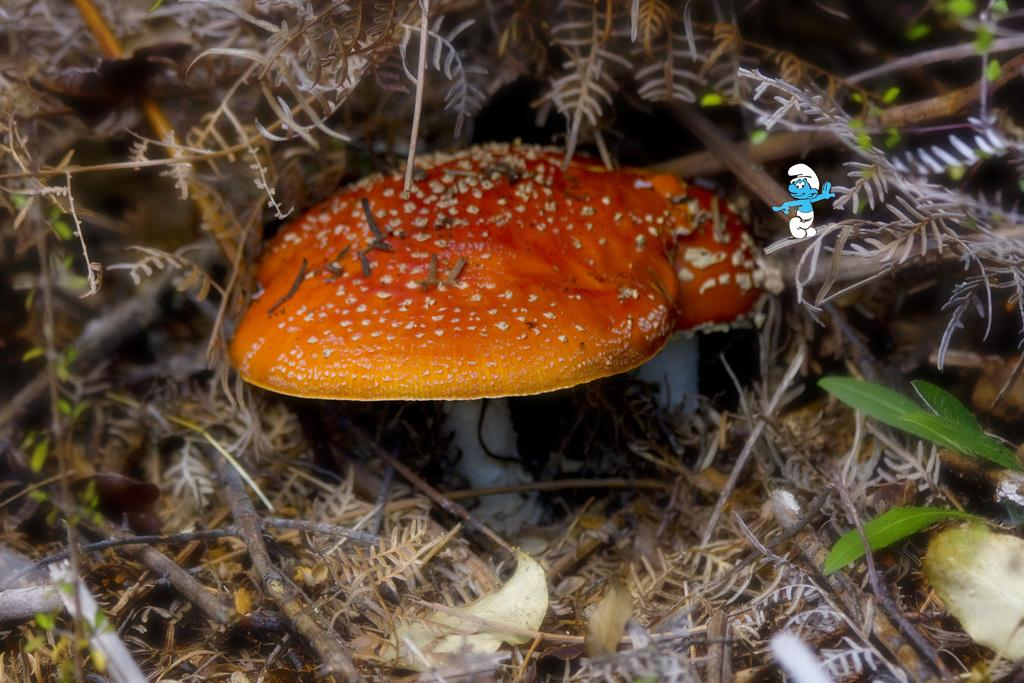What type of natural objects can be seen on the ground in the image? There are mushrooms on the ground in the image. What other natural elements are present in the image? There are leaves in the image. Are there any additional objects visible in the image? Yes, there are sticks in the image. Can you describe the unspecified objects in the image? Unfortunately, the facts provided do not specify the nature of these objects, so we cannot describe them. What type of silk fabric is draped over the mushrooms in the image? There is no silk fabric present in the image; it features mushrooms, leaves, and sticks. 